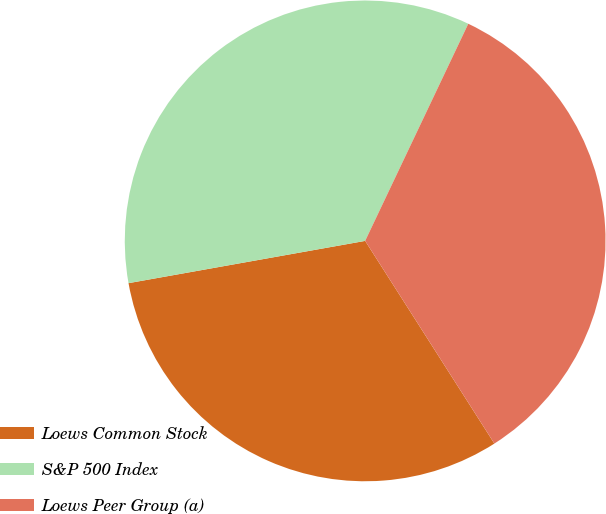Convert chart. <chart><loc_0><loc_0><loc_500><loc_500><pie_chart><fcel>Loews Common Stock<fcel>S&P 500 Index<fcel>Loews Peer Group (a)<nl><fcel>31.22%<fcel>34.87%<fcel>33.91%<nl></chart> 